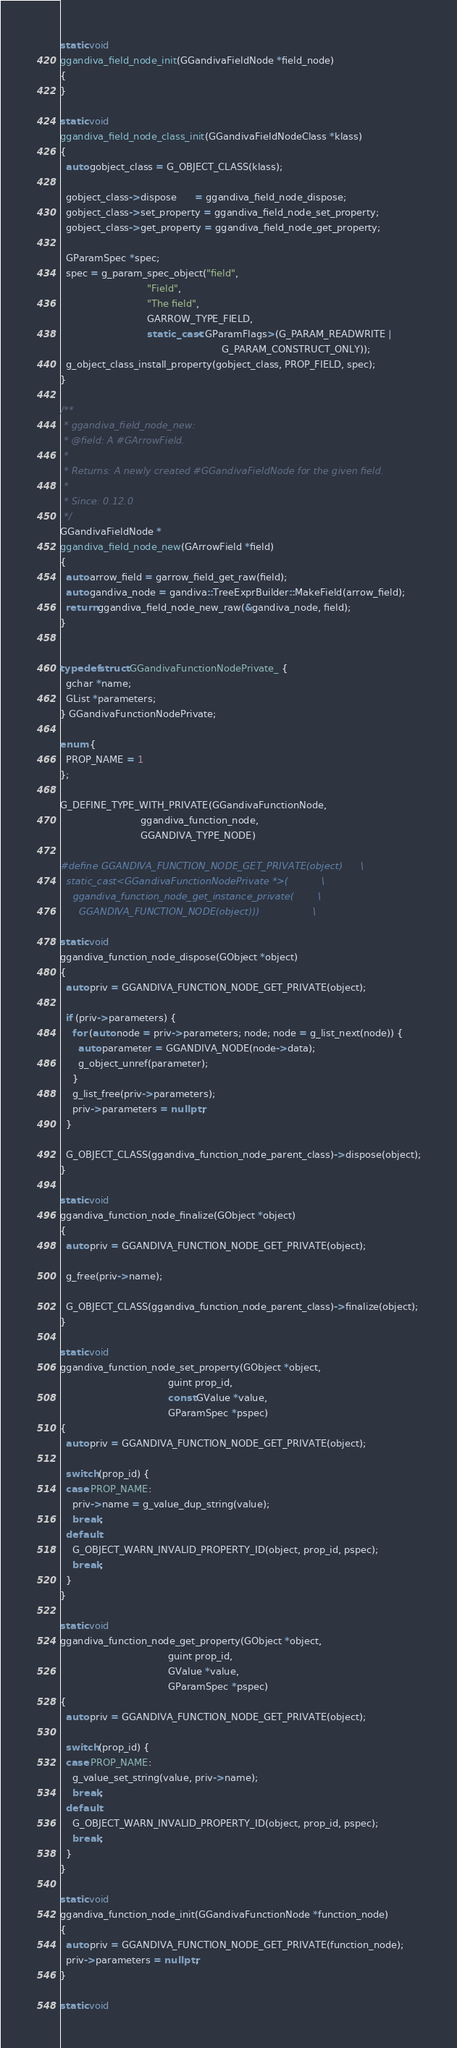Convert code to text. <code><loc_0><loc_0><loc_500><loc_500><_C++_>static void
ggandiva_field_node_init(GGandivaFieldNode *field_node)
{
}

static void
ggandiva_field_node_class_init(GGandivaFieldNodeClass *klass)
{
  auto gobject_class = G_OBJECT_CLASS(klass);

  gobject_class->dispose      = ggandiva_field_node_dispose;
  gobject_class->set_property = ggandiva_field_node_set_property;
  gobject_class->get_property = ggandiva_field_node_get_property;

  GParamSpec *spec;
  spec = g_param_spec_object("field",
                             "Field",
                             "The field",
                             GARROW_TYPE_FIELD,
                             static_cast<GParamFlags>(G_PARAM_READWRITE |
                                                      G_PARAM_CONSTRUCT_ONLY));
  g_object_class_install_property(gobject_class, PROP_FIELD, spec);
}

/**
 * ggandiva_field_node_new:
 * @field: A #GArrowField.
 *
 * Returns: A newly created #GGandivaFieldNode for the given field.
 *
 * Since: 0.12.0
 */
GGandivaFieldNode *
ggandiva_field_node_new(GArrowField *field)
{
  auto arrow_field = garrow_field_get_raw(field);
  auto gandiva_node = gandiva::TreeExprBuilder::MakeField(arrow_field);
  return ggandiva_field_node_new_raw(&gandiva_node, field);
}


typedef struct GGandivaFunctionNodePrivate_ {
  gchar *name;
  GList *parameters;
} GGandivaFunctionNodePrivate;

enum {
  PROP_NAME = 1
};

G_DEFINE_TYPE_WITH_PRIVATE(GGandivaFunctionNode,
                           ggandiva_function_node,
                           GGANDIVA_TYPE_NODE)

#define GGANDIVA_FUNCTION_NODE_GET_PRIVATE(object)      \
  static_cast<GGandivaFunctionNodePrivate *>(           \
    ggandiva_function_node_get_instance_private(        \
      GGANDIVA_FUNCTION_NODE(object)))                  \

static void
ggandiva_function_node_dispose(GObject *object)
{
  auto priv = GGANDIVA_FUNCTION_NODE_GET_PRIVATE(object);

  if (priv->parameters) {
    for (auto node = priv->parameters; node; node = g_list_next(node)) {
      auto parameter = GGANDIVA_NODE(node->data);
      g_object_unref(parameter);
    }
    g_list_free(priv->parameters);
    priv->parameters = nullptr;
  }

  G_OBJECT_CLASS(ggandiva_function_node_parent_class)->dispose(object);
}

static void
ggandiva_function_node_finalize(GObject *object)
{
  auto priv = GGANDIVA_FUNCTION_NODE_GET_PRIVATE(object);

  g_free(priv->name);

  G_OBJECT_CLASS(ggandiva_function_node_parent_class)->finalize(object);
}

static void
ggandiva_function_node_set_property(GObject *object,
                                    guint prop_id,
                                    const GValue *value,
                                    GParamSpec *pspec)
{
  auto priv = GGANDIVA_FUNCTION_NODE_GET_PRIVATE(object);

  switch (prop_id) {
  case PROP_NAME:
    priv->name = g_value_dup_string(value);
    break;
  default:
    G_OBJECT_WARN_INVALID_PROPERTY_ID(object, prop_id, pspec);
    break;
  }
}

static void
ggandiva_function_node_get_property(GObject *object,
                                    guint prop_id,
                                    GValue *value,
                                    GParamSpec *pspec)
{
  auto priv = GGANDIVA_FUNCTION_NODE_GET_PRIVATE(object);

  switch (prop_id) {
  case PROP_NAME:
    g_value_set_string(value, priv->name);
    break;
  default:
    G_OBJECT_WARN_INVALID_PROPERTY_ID(object, prop_id, pspec);
    break;
  }
}

static void
ggandiva_function_node_init(GGandivaFunctionNode *function_node)
{
  auto priv = GGANDIVA_FUNCTION_NODE_GET_PRIVATE(function_node);
  priv->parameters = nullptr;
}

static void</code> 